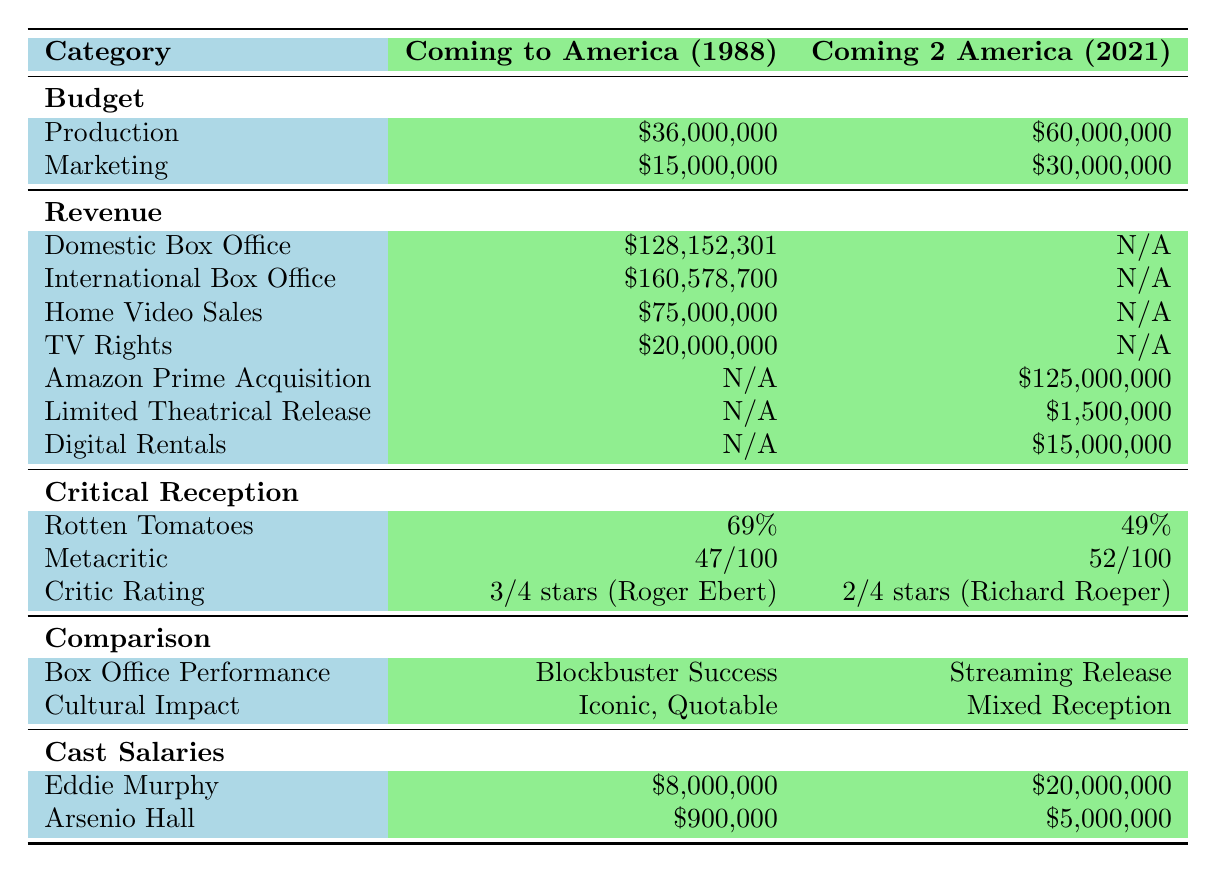What is the total production budget for both movies? The production budget for "Coming to America" is $36,000,000, and for "Coming 2 America," it is $60,000,000. Adding these gives us $36,000,000 + $60,000,000 = $96,000,000.
Answer: $96,000,000 How much more did the sequel spend on marketing compared to the original? The marketing budget for "Coming to America" is $15,000,000, while for "Coming 2 America," it is $30,000,000. The difference is $30,000,000 - $15,000,000 = $15,000,000.
Answer: $15,000,000 What is the total domestic and international box office revenue for the original film? The domestic box office revenue is $128,152,301, and the international box office revenue is $160,578,700. Adding these gives us $128,152,301 + $160,578,700 = $288,731,001.
Answer: $288,731,001 Did "Coming 2 America" earn any revenue from domestic box office sales? There is no entry for domestic box office revenue for "Coming 2 America," indicating that it did not earn any revenue in this category.
Answer: No Which film received a higher rating from Rotten Tomatoes? "Coming to America" has a Rotten Tomatoes rating of 69%, while "Coming 2 America" has a rating of 49%. Since 69% is greater than 49%, the original film received a higher rating.
Answer: "Coming to America" What is the total revenue earned from home video sales and TV rights for the original film? The home video sales for "Coming to America" are $75,000,000, and the TV rights revenue is $20,000,000. Adding these gives us $75,000,000 + $20,000,000 = $95,000,000.
Answer: $95,000,000 How do Eddie Murphy's salaries compare between the two movies? Eddie Murphy was paid $8,000,000 for "Coming to America" and $20,000,000 for "Coming 2 America." Subtracting these gives us $20,000,000 - $8,000,000 = $12,000,000, indicating he earned $12,000,000 more for the sequel.
Answer: $12,000,000 What type of release did "Coming 2 America" have compared to the original in terms of box office performance? According to the table, "Coming to America" had a "Blockbuster Success" performance while "Coming 2 America" was categorized as "Streaming Release."
Answer: Streaming Release What was the average rating from critics for both films? "Coming to America" received a critic rating of 3/4 stars, equivalent to 75%. "Coming 2 America" received 2/4 stars, equivalent to 50%. The average rating is (75% + 50%) / 2 = 62.5%.
Answer: 62.5% Which film had a better overall cultural impact according to the table? The table states that the original film is "Iconic, Quotable," while the sequel is described as having a "Mixed Reception." Given these descriptions, the original had a better overall cultural impact.
Answer: The original film How much total revenue does "Coming 2 America" earn from Amazon Prime Acquisition, Limited Theatrical Release, and Digital Rentals? "Coming 2 America" earns $125,000,000 from Amazon Prime Acquisition, $1,500,000 from Limited Theatrical Release, and $15,000,000 from Digital Rentals. Adding these values gives $125,000,000 + $1,500,000 + $15,000,000 = $141,500,000.
Answer: $141,500,000 